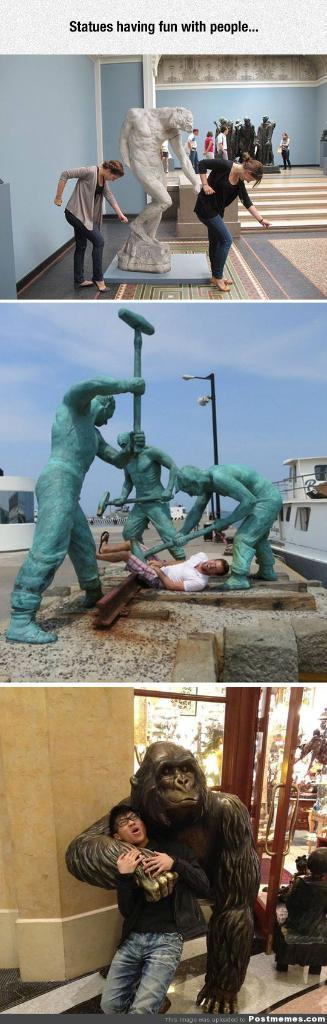What type of image is shown in the picture? The image is a photo collage. What types of objects can be seen in the photo collage? There are statues in the photo collage. Are there any living subjects in the photo collage? Yes, there are people in the photo collage. What type of apparatus is being used by the people in the photo collage? There is no apparatus visible in the photo collage; it only features statues and people. Is there a tent present in the photo collage? No, there is no tent present in the photo collage. Can you see any light bulbs in the photo collage? No, there are no light bulbs visible in the photo collage. 